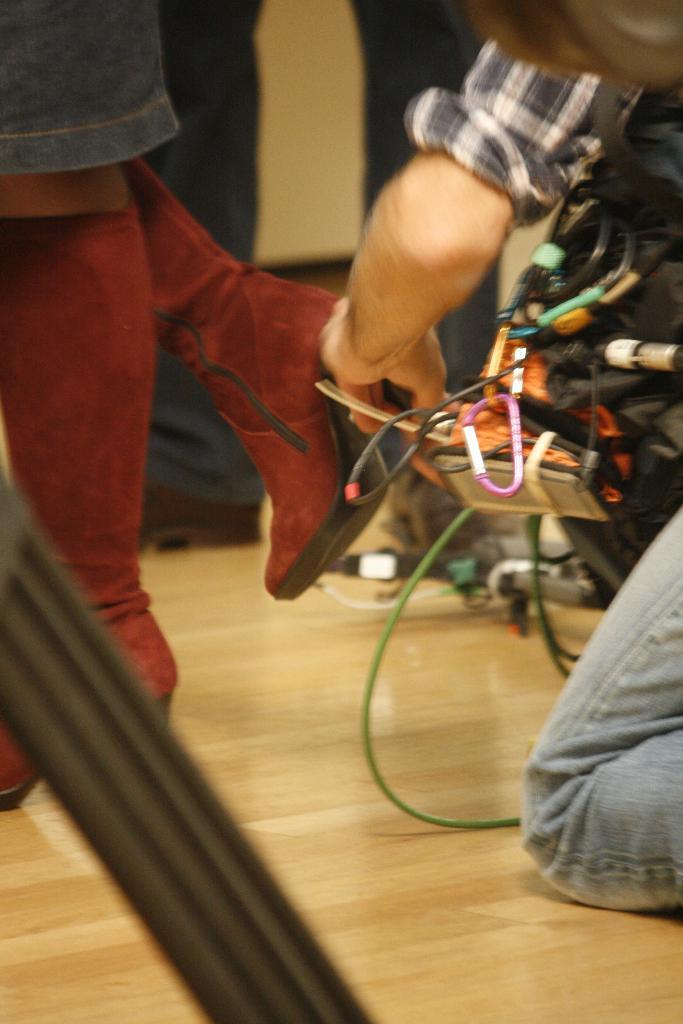In one or two sentences, can you explain what this image depicts? In this picture there is a person holding wires. He is wearing a check shirt and blue jeans. He is towards the right. Towards the left, there is a person legs can be seen. 